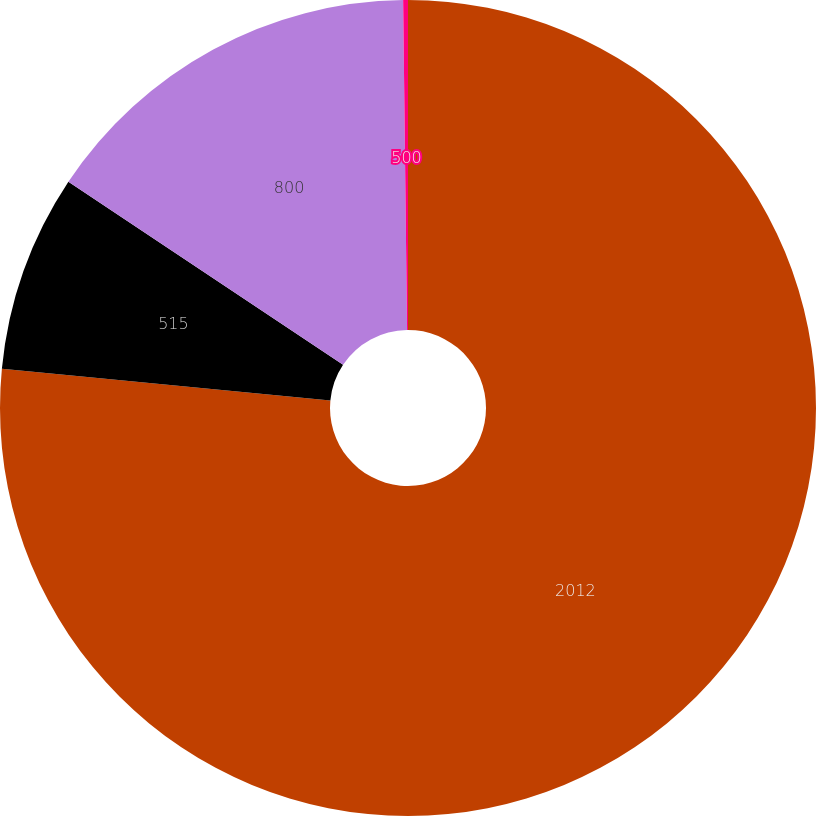Convert chart. <chart><loc_0><loc_0><loc_500><loc_500><pie_chart><fcel>2012<fcel>515<fcel>800<fcel>500<nl><fcel>76.53%<fcel>7.82%<fcel>15.46%<fcel>0.19%<nl></chart> 